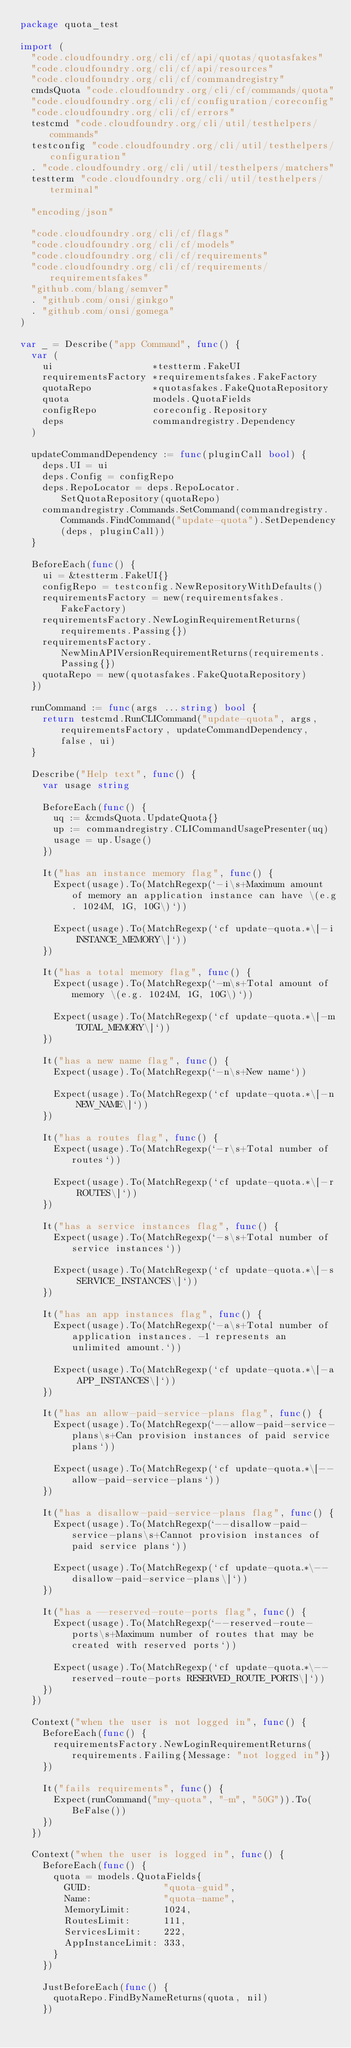<code> <loc_0><loc_0><loc_500><loc_500><_Go_>package quota_test

import (
	"code.cloudfoundry.org/cli/cf/api/quotas/quotasfakes"
	"code.cloudfoundry.org/cli/cf/api/resources"
	"code.cloudfoundry.org/cli/cf/commandregistry"
	cmdsQuota "code.cloudfoundry.org/cli/cf/commands/quota"
	"code.cloudfoundry.org/cli/cf/configuration/coreconfig"
	"code.cloudfoundry.org/cli/cf/errors"
	testcmd "code.cloudfoundry.org/cli/util/testhelpers/commands"
	testconfig "code.cloudfoundry.org/cli/util/testhelpers/configuration"
	. "code.cloudfoundry.org/cli/util/testhelpers/matchers"
	testterm "code.cloudfoundry.org/cli/util/testhelpers/terminal"

	"encoding/json"

	"code.cloudfoundry.org/cli/cf/flags"
	"code.cloudfoundry.org/cli/cf/models"
	"code.cloudfoundry.org/cli/cf/requirements"
	"code.cloudfoundry.org/cli/cf/requirements/requirementsfakes"
	"github.com/blang/semver"
	. "github.com/onsi/ginkgo"
	. "github.com/onsi/gomega"
)

var _ = Describe("app Command", func() {
	var (
		ui                  *testterm.FakeUI
		requirementsFactory *requirementsfakes.FakeFactory
		quotaRepo           *quotasfakes.FakeQuotaRepository
		quota               models.QuotaFields
		configRepo          coreconfig.Repository
		deps                commandregistry.Dependency
	)

	updateCommandDependency := func(pluginCall bool) {
		deps.UI = ui
		deps.Config = configRepo
		deps.RepoLocator = deps.RepoLocator.SetQuotaRepository(quotaRepo)
		commandregistry.Commands.SetCommand(commandregistry.Commands.FindCommand("update-quota").SetDependency(deps, pluginCall))
	}

	BeforeEach(func() {
		ui = &testterm.FakeUI{}
		configRepo = testconfig.NewRepositoryWithDefaults()
		requirementsFactory = new(requirementsfakes.FakeFactory)
		requirementsFactory.NewLoginRequirementReturns(requirements.Passing{})
		requirementsFactory.NewMinAPIVersionRequirementReturns(requirements.Passing{})
		quotaRepo = new(quotasfakes.FakeQuotaRepository)
	})

	runCommand := func(args ...string) bool {
		return testcmd.RunCLICommand("update-quota", args, requirementsFactory, updateCommandDependency, false, ui)
	}

	Describe("Help text", func() {
		var usage string

		BeforeEach(func() {
			uq := &cmdsQuota.UpdateQuota{}
			up := commandregistry.CLICommandUsagePresenter(uq)
			usage = up.Usage()
		})

		It("has an instance memory flag", func() {
			Expect(usage).To(MatchRegexp(`-i\s+Maximum amount of memory an application instance can have \(e.g. 1024M, 1G, 10G\)`))

			Expect(usage).To(MatchRegexp(`cf update-quota.*\[-i INSTANCE_MEMORY\]`))
		})

		It("has a total memory flag", func() {
			Expect(usage).To(MatchRegexp(`-m\s+Total amount of memory \(e.g. 1024M, 1G, 10G\)`))

			Expect(usage).To(MatchRegexp(`cf update-quota.*\[-m TOTAL_MEMORY\]`))
		})

		It("has a new name flag", func() {
			Expect(usage).To(MatchRegexp(`-n\s+New name`))

			Expect(usage).To(MatchRegexp(`cf update-quota.*\[-n NEW_NAME\]`))
		})

		It("has a routes flag", func() {
			Expect(usage).To(MatchRegexp(`-r\s+Total number of routes`))

			Expect(usage).To(MatchRegexp(`cf update-quota.*\[-r ROUTES\]`))
		})

		It("has a service instances flag", func() {
			Expect(usage).To(MatchRegexp(`-s\s+Total number of service instances`))

			Expect(usage).To(MatchRegexp(`cf update-quota.*\[-s SERVICE_INSTANCES\]`))
		})

		It("has an app instances flag", func() {
			Expect(usage).To(MatchRegexp(`-a\s+Total number of application instances. -1 represents an unlimited amount.`))

			Expect(usage).To(MatchRegexp(`cf update-quota.*\[-a APP_INSTANCES\]`))
		})

		It("has an allow-paid-service-plans flag", func() {
			Expect(usage).To(MatchRegexp(`--allow-paid-service-plans\s+Can provision instances of paid service plans`))

			Expect(usage).To(MatchRegexp(`cf update-quota.*\[--allow-paid-service-plans`))
		})

		It("has a disallow-paid-service-plans flag", func() {
			Expect(usage).To(MatchRegexp(`--disallow-paid-service-plans\s+Cannot provision instances of paid service plans`))

			Expect(usage).To(MatchRegexp(`cf update-quota.*\--disallow-paid-service-plans\]`))
		})

		It("has a --reserved-route-ports flag", func() {
			Expect(usage).To(MatchRegexp(`--reserved-route-ports\s+Maximum number of routes that may be created with reserved ports`))

			Expect(usage).To(MatchRegexp(`cf update-quota.*\--reserved-route-ports RESERVED_ROUTE_PORTS\]`))
		})
	})

	Context("when the user is not logged in", func() {
		BeforeEach(func() {
			requirementsFactory.NewLoginRequirementReturns(requirements.Failing{Message: "not logged in"})
		})

		It("fails requirements", func() {
			Expect(runCommand("my-quota", "-m", "50G")).To(BeFalse())
		})
	})

	Context("when the user is logged in", func() {
		BeforeEach(func() {
			quota = models.QuotaFields{
				GUID:             "quota-guid",
				Name:             "quota-name",
				MemoryLimit:      1024,
				RoutesLimit:      111,
				ServicesLimit:    222,
				AppInstanceLimit: 333,
			}
		})

		JustBeforeEach(func() {
			quotaRepo.FindByNameReturns(quota, nil)
		})
</code> 